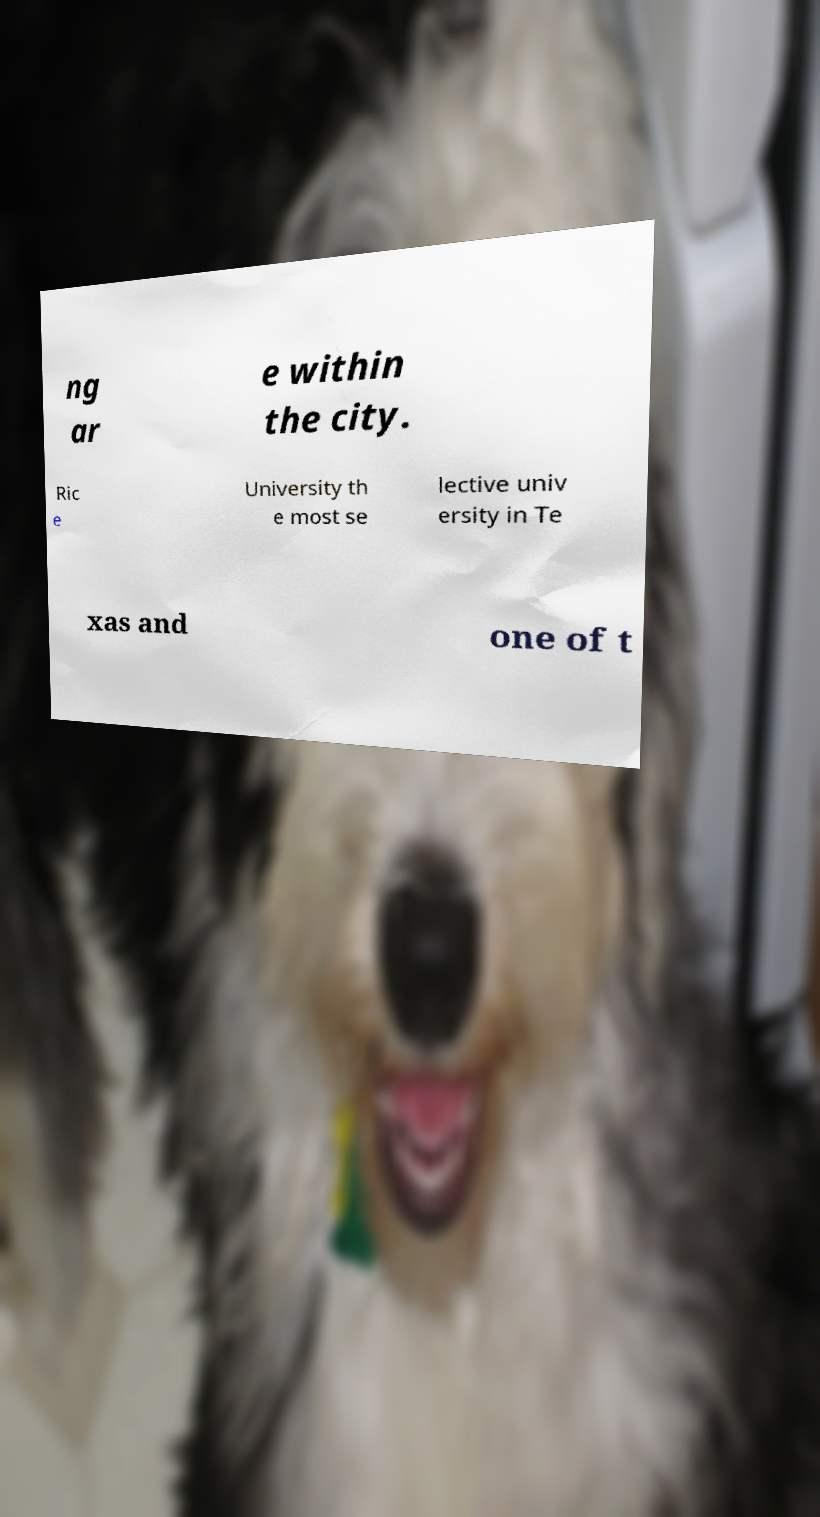Can you accurately transcribe the text from the provided image for me? ng ar e within the city. Ric e University th e most se lective univ ersity in Te xas and one of t 